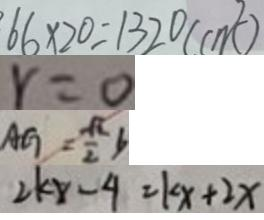Convert formula to latex. <formula><loc_0><loc_0><loc_500><loc_500>6 6 \times 2 0 = 1 3 2 0 ( c m ^ { 2 } ) 
 r = 0 
 A G = \frac { \sqrt { 2 } } { 2 } b 
 2 k x - 4 = k x + 2 x</formula> 